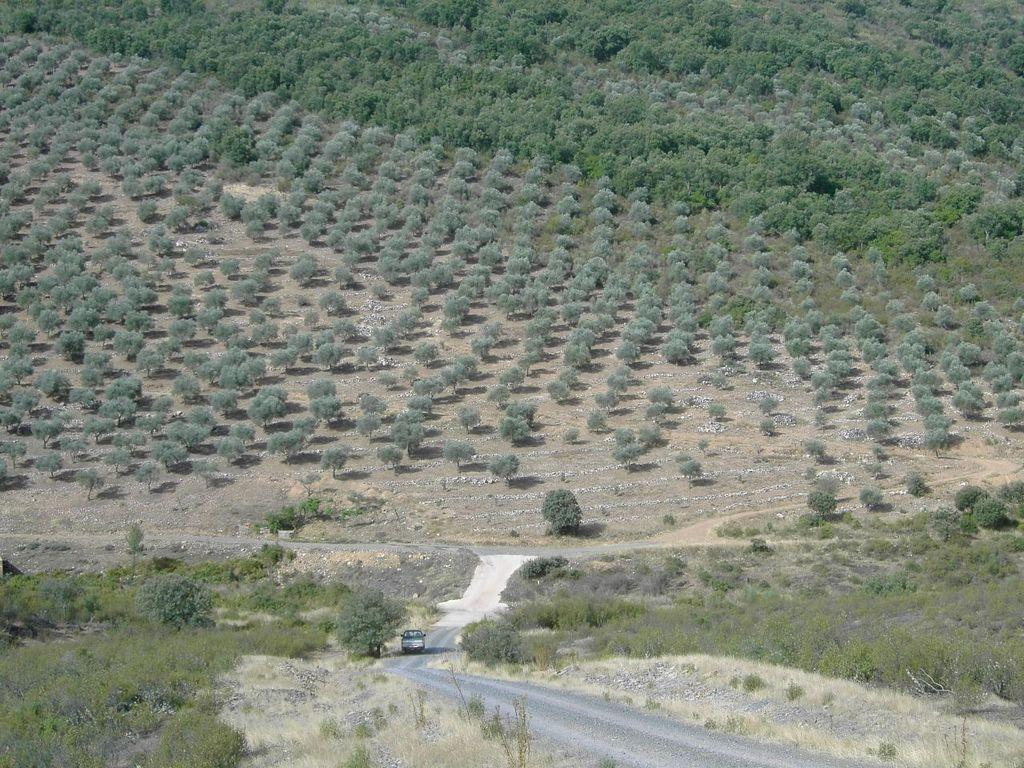What is the main subject of the image? There is a vehicle in the image. What is the vehicle doing in the image? The vehicle is moving on the road. What can be seen in the background of the image? There are trees visible in the image. What type of sand can be seen on the vehicle in the image? There is no sand present on the vehicle in the image. What idea does the vehicle represent in the image? The image does not convey any specific ideas or concepts related to the vehicle. 